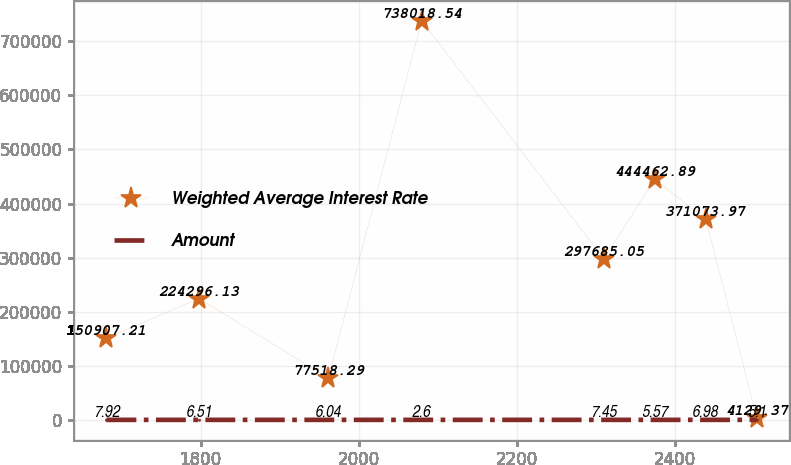Convert chart. <chart><loc_0><loc_0><loc_500><loc_500><line_chart><ecel><fcel>Weighted Average Interest Rate<fcel>Amount<nl><fcel>1680.96<fcel>150907<fcel>7.92<nl><fcel>1797.78<fcel>224296<fcel>6.51<nl><fcel>1961.64<fcel>77518.3<fcel>6.04<nl><fcel>2079.64<fcel>738019<fcel>2.6<nl><fcel>2310.12<fcel>297685<fcel>7.45<nl><fcel>2374.58<fcel>444463<fcel>5.57<nl><fcel>2439.04<fcel>371074<fcel>6.98<nl><fcel>2503.5<fcel>4129.37<fcel>5.1<nl></chart> 